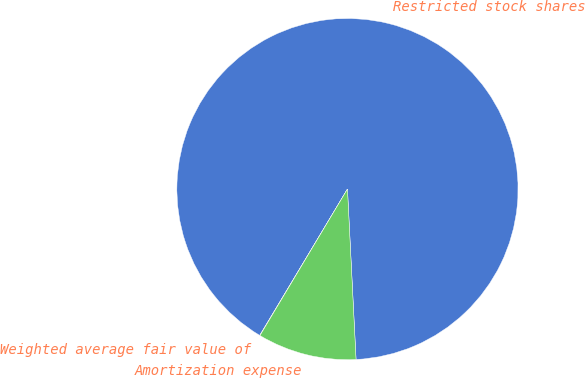Convert chart. <chart><loc_0><loc_0><loc_500><loc_500><pie_chart><fcel>Restricted stock shares<fcel>Weighted average fair value of<fcel>Amortization expense<nl><fcel>90.6%<fcel>0.03%<fcel>9.37%<nl></chart> 